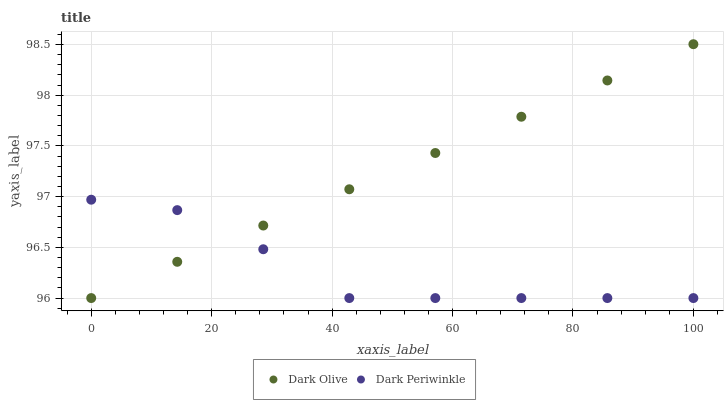Does Dark Periwinkle have the minimum area under the curve?
Answer yes or no. Yes. Does Dark Olive have the maximum area under the curve?
Answer yes or no. Yes. Does Dark Periwinkle have the maximum area under the curve?
Answer yes or no. No. Is Dark Olive the smoothest?
Answer yes or no. Yes. Is Dark Periwinkle the roughest?
Answer yes or no. Yes. Is Dark Periwinkle the smoothest?
Answer yes or no. No. Does Dark Olive have the lowest value?
Answer yes or no. Yes. Does Dark Olive have the highest value?
Answer yes or no. Yes. Does Dark Periwinkle have the highest value?
Answer yes or no. No. Does Dark Olive intersect Dark Periwinkle?
Answer yes or no. Yes. Is Dark Olive less than Dark Periwinkle?
Answer yes or no. No. Is Dark Olive greater than Dark Periwinkle?
Answer yes or no. No. 